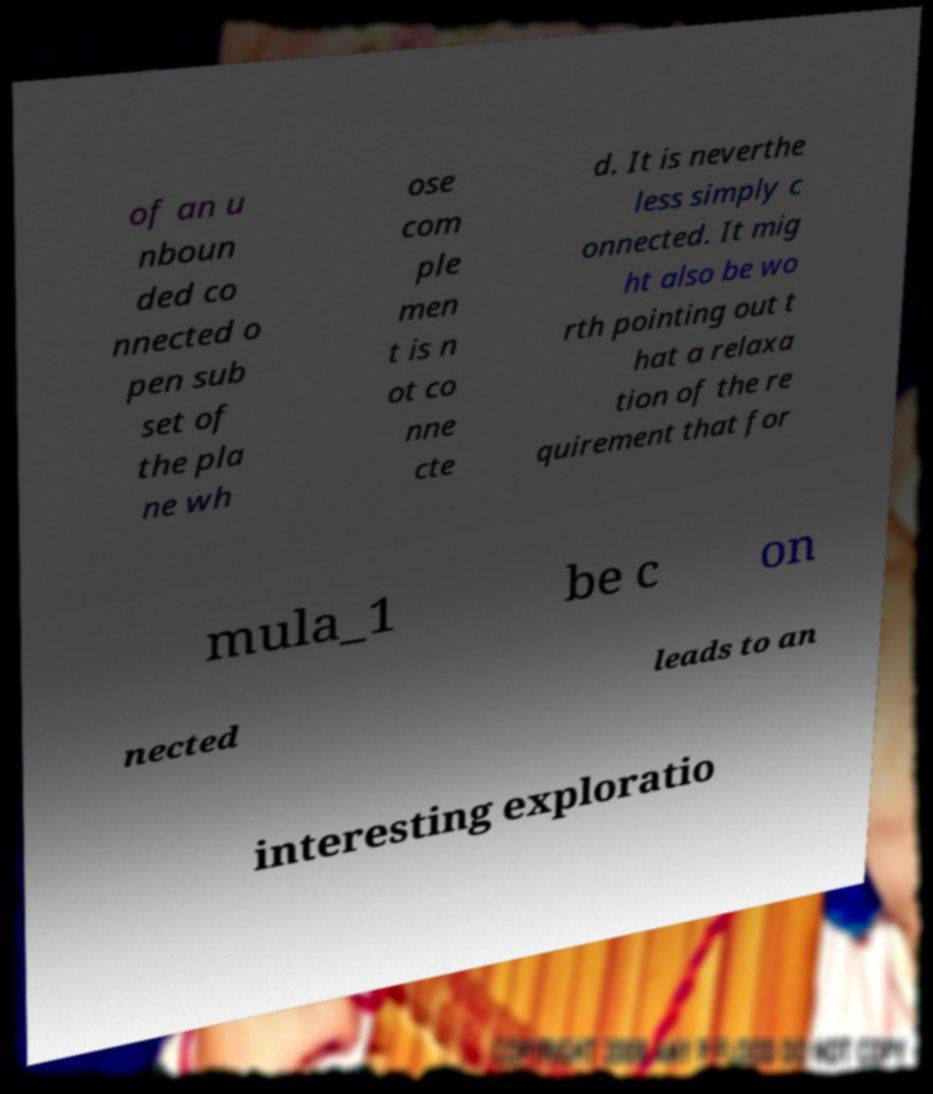What messages or text are displayed in this image? I need them in a readable, typed format. of an u nboun ded co nnected o pen sub set of the pla ne wh ose com ple men t is n ot co nne cte d. It is neverthe less simply c onnected. It mig ht also be wo rth pointing out t hat a relaxa tion of the re quirement that for mula_1 be c on nected leads to an interesting exploratio 